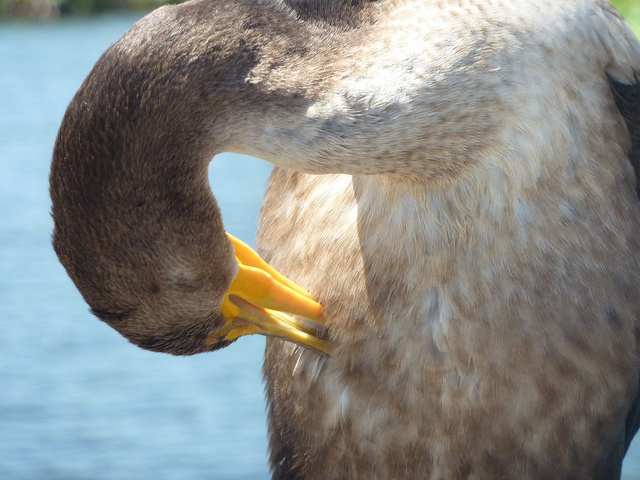Describe the objects in this image and their specific colors. I can see a bird in gray, darkgreen, darkgray, black, and ivory tones in this image. 